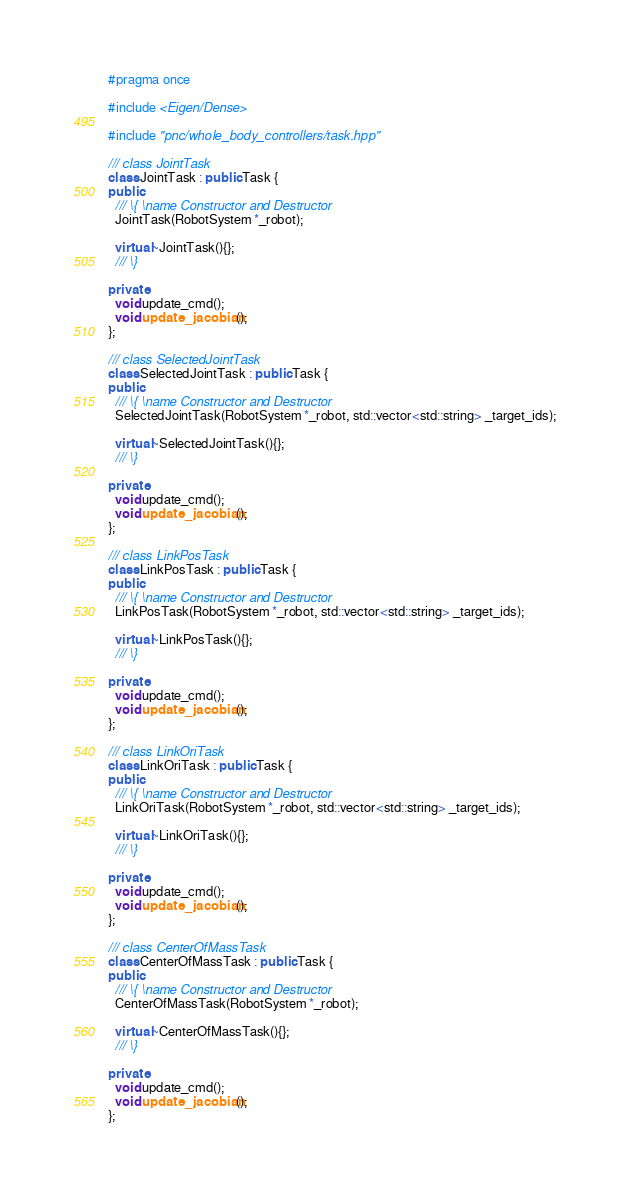Convert code to text. <code><loc_0><loc_0><loc_500><loc_500><_C++_>#pragma once

#include <Eigen/Dense>

#include "pnc/whole_body_controllers/task.hpp"

/// class JointTask
class JointTask : public Task {
public:
  /// \{ \name Constructor and Destructor
  JointTask(RobotSystem *_robot);

  virtual ~JointTask(){};
  /// \}

private:
  void update_cmd();
  void update_jacobian();
};

/// class SelectedJointTask
class SelectedJointTask : public Task {
public:
  /// \{ \name Constructor and Destructor
  SelectedJointTask(RobotSystem *_robot, std::vector<std::string> _target_ids);

  virtual ~SelectedJointTask(){};
  /// \}

private:
  void update_cmd();
  void update_jacobian();
};

/// class LinkPosTask
class LinkPosTask : public Task {
public:
  /// \{ \name Constructor and Destructor
  LinkPosTask(RobotSystem *_robot, std::vector<std::string> _target_ids);

  virtual ~LinkPosTask(){};
  /// \}

private:
  void update_cmd();
  void update_jacobian();
};

/// class LinkOriTask
class LinkOriTask : public Task {
public:
  /// \{ \name Constructor and Destructor
  LinkOriTask(RobotSystem *_robot, std::vector<std::string> _target_ids);

  virtual ~LinkOriTask(){};
  /// \}

private:
  void update_cmd();
  void update_jacobian();
};

/// class CenterOfMassTask
class CenterOfMassTask : public Task {
public:
  /// \{ \name Constructor and Destructor
  CenterOfMassTask(RobotSystem *_robot);

  virtual ~CenterOfMassTask(){};
  /// \}

private:
  void update_cmd();
  void update_jacobian();
};
</code> 